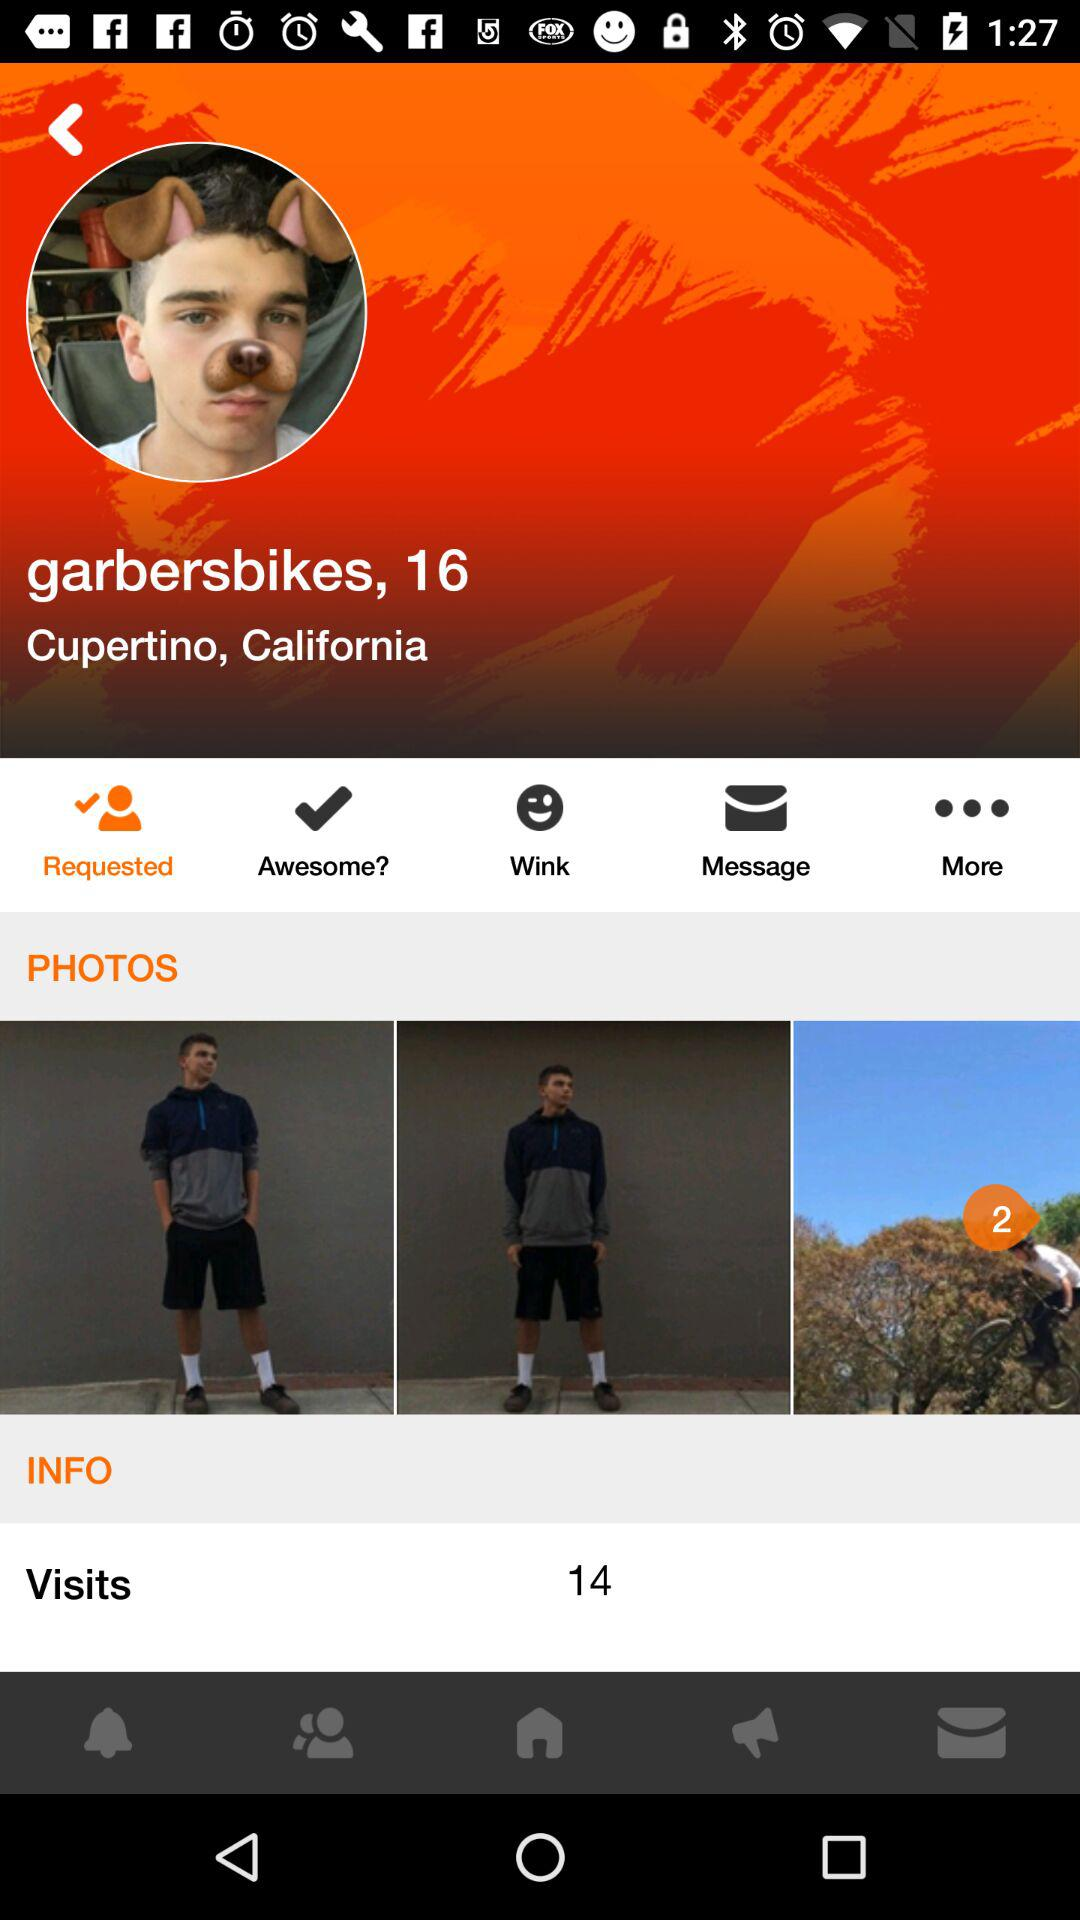How many visits are there on the user's profile? There are 14 visits on the user's profile. 